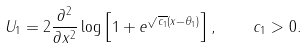Convert formula to latex. <formula><loc_0><loc_0><loc_500><loc_500>U _ { 1 } = 2 \frac { \partial ^ { 2 } } { \partial x ^ { 2 } } \log \left [ 1 + e ^ { \sqrt { c _ { 1 } } ( x - \theta _ { 1 } ) } \right ] , \quad c _ { 1 } > 0 .</formula> 